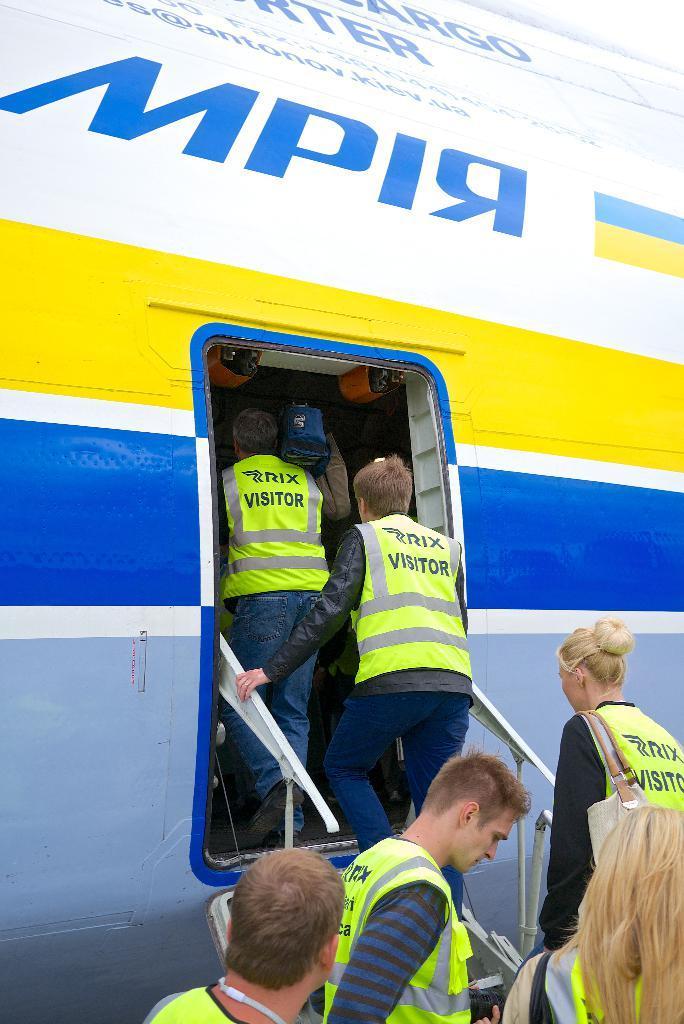In one or two sentences, can you explain what this image depicts? In the image there are few people boarding into a plane. 